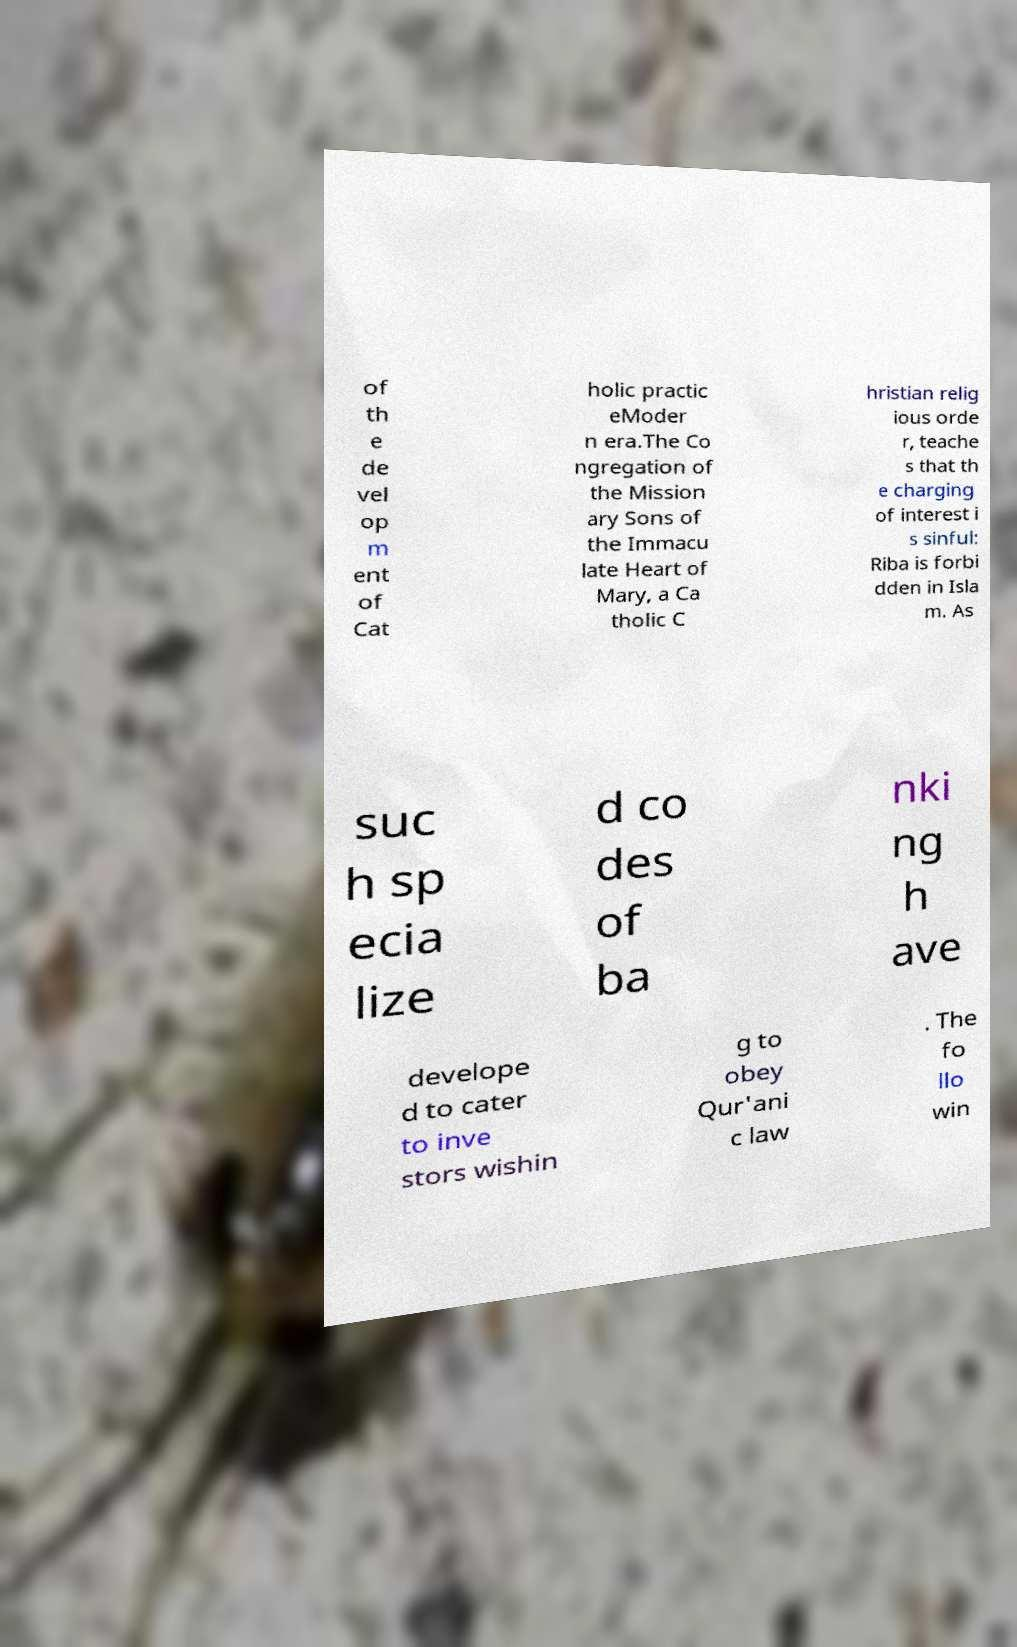Could you assist in decoding the text presented in this image and type it out clearly? of th e de vel op m ent of Cat holic practic eModer n era.The Co ngregation of the Mission ary Sons of the Immacu late Heart of Mary, a Ca tholic C hristian relig ious orde r, teache s that th e charging of interest i s sinful: Riba is forbi dden in Isla m. As suc h sp ecia lize d co des of ba nki ng h ave develope d to cater to inve stors wishin g to obey Qur'ani c law . The fo llo win 